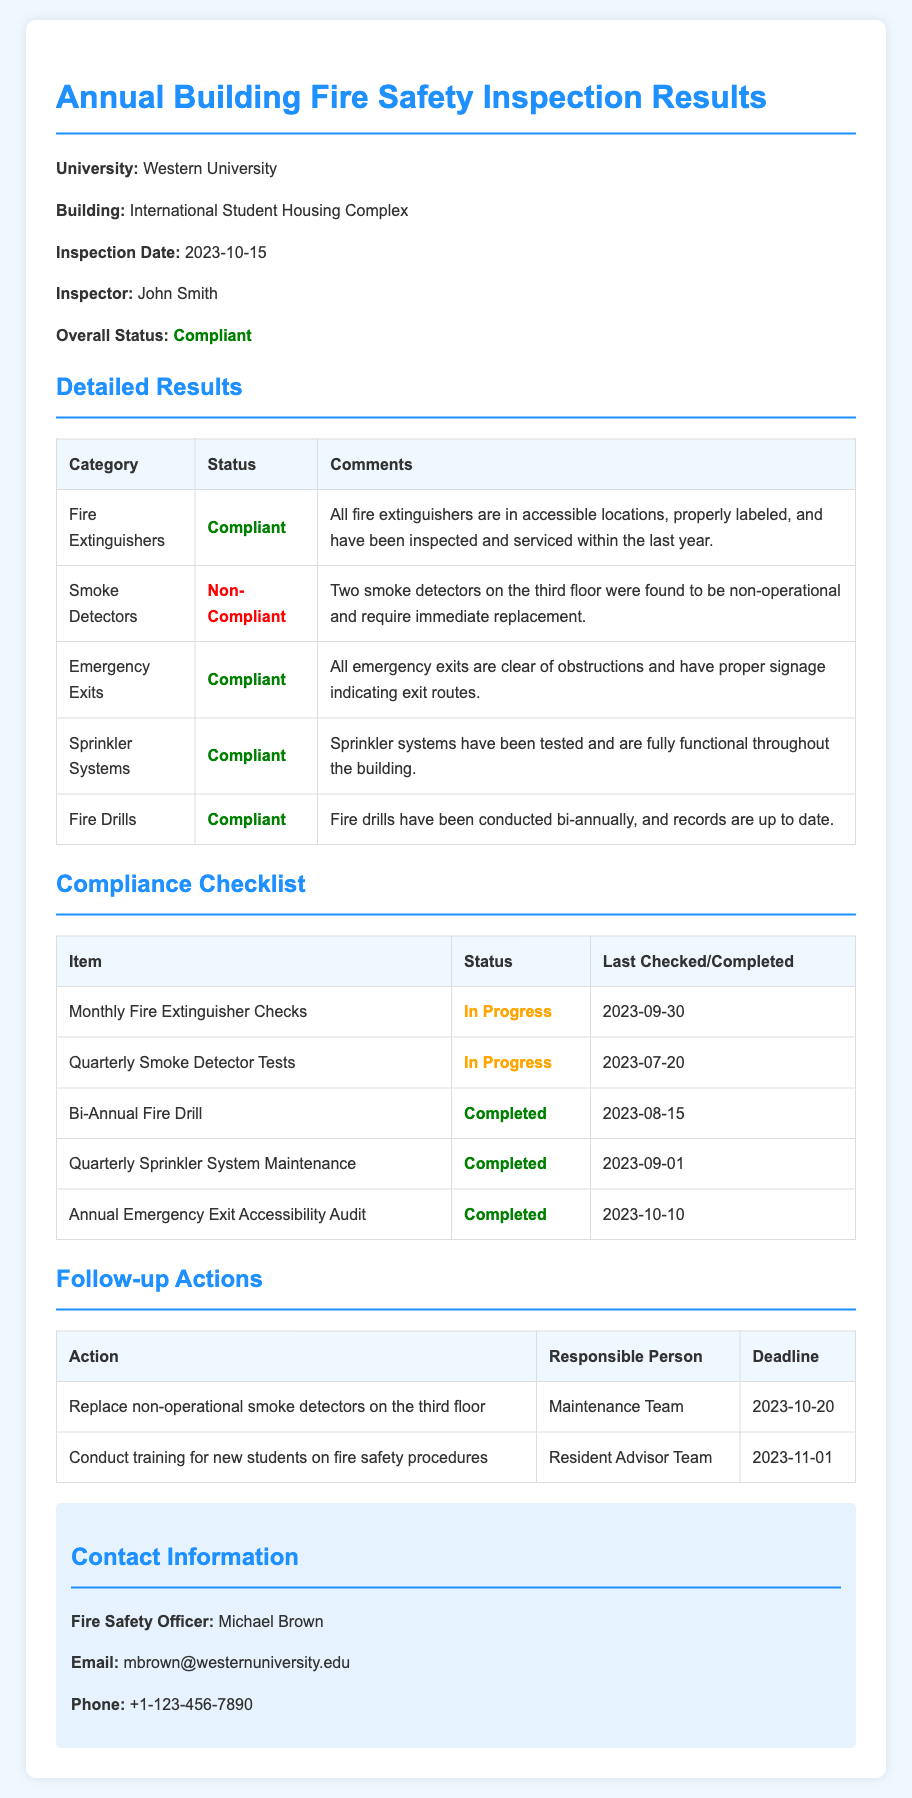What is the name of the university? The university is specifically mentioned in the document as "Western University."
Answer: Western University What is the inspection date? The inspection date is clearly stated in the document as "2023-10-15."
Answer: 2023-10-15 Who conducted the inspection? The inspector's name is provided in the document, which is "John Smith."
Answer: John Smith What is the status of the fire extinguishers? The document specifies the status of fire extinguishers as "Compliant."
Answer: Compliant How many smoke detectors were non-operational? The document mentions that "Two smoke detectors on the third floor were found to be non-operational."
Answer: Two What is the deadline for replacing non-operational smoke detectors? The document states the deadline for this action as "2023-10-20."
Answer: 2023-10-20 How many emergency exits are compliant? The document indicates that "All emergency exits are clear of obstructions," therefore all are compliant.
Answer: All What type of training will be conducted for new students? The document specifies the training as "training for new students on fire safety procedures."
Answer: Fire safety procedures What category has a non-compliant status? The document identifies the "Smoke Detectors" category as non-compliant.
Answer: Smoke Detectors 